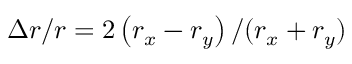Convert formula to latex. <formula><loc_0><loc_0><loc_500><loc_500>\Delta r / r = 2 \left ( r _ { x } - r _ { y } \right ) / ( r _ { x } + r _ { y } )</formula> 